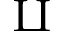<formula> <loc_0><loc_0><loc_500><loc_500>\amalg</formula> 